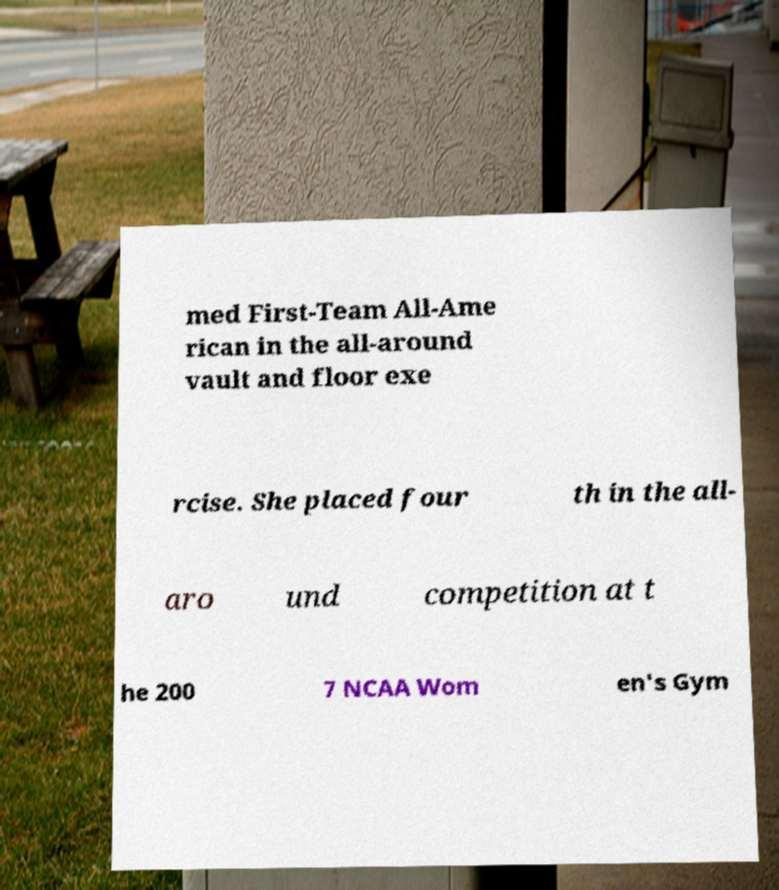Please read and relay the text visible in this image. What does it say? med First-Team All-Ame rican in the all-around vault and floor exe rcise. She placed four th in the all- aro und competition at t he 200 7 NCAA Wom en's Gym 